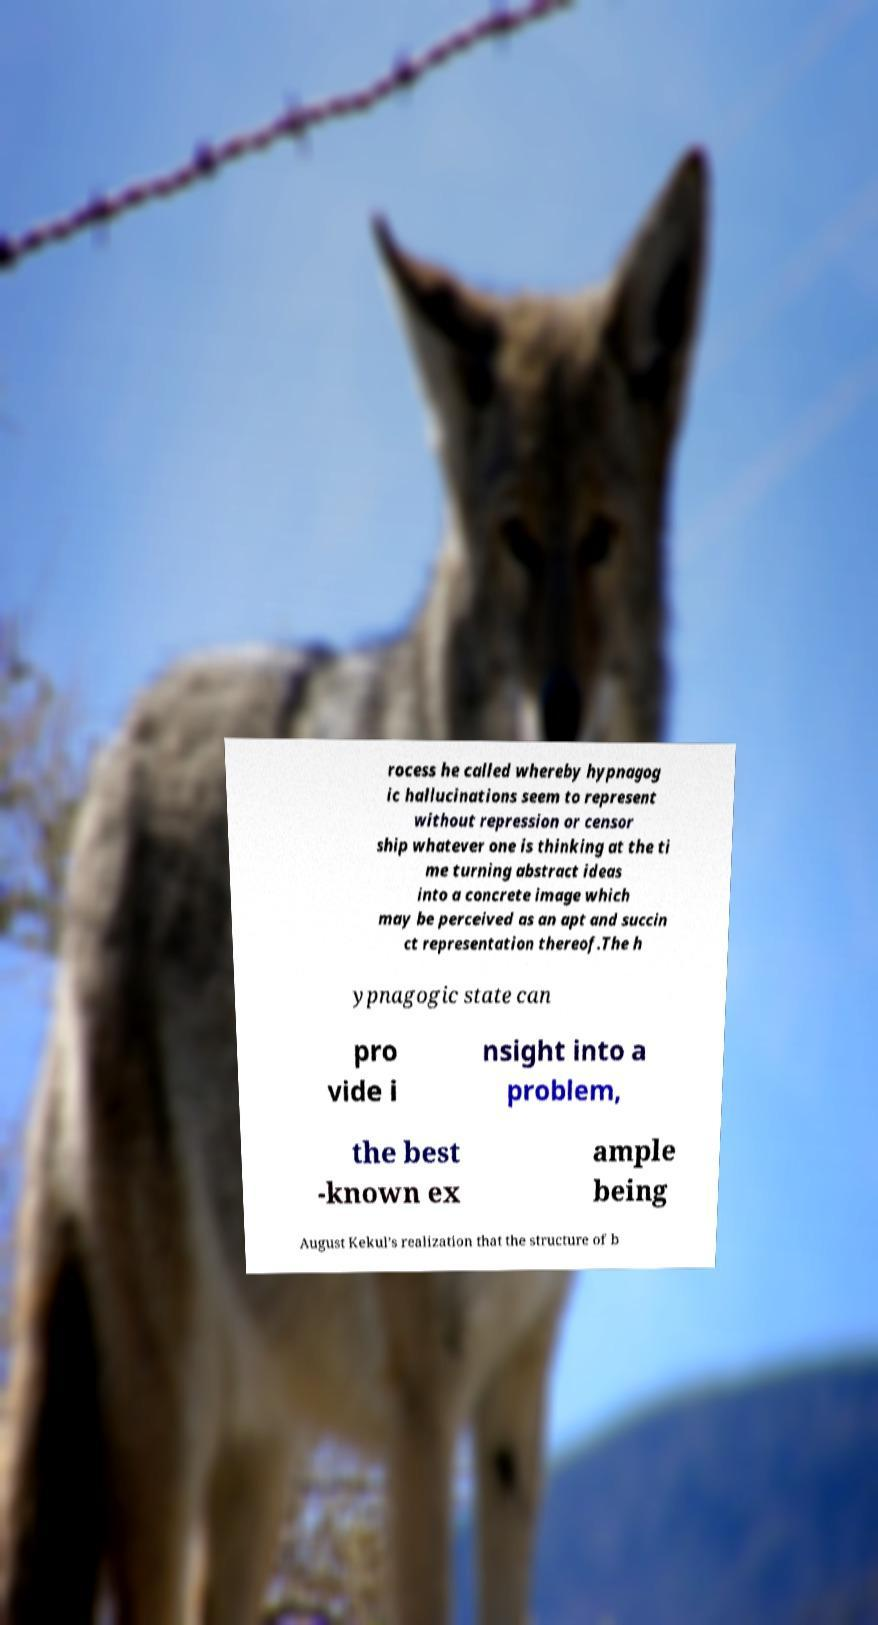There's text embedded in this image that I need extracted. Can you transcribe it verbatim? rocess he called whereby hypnagog ic hallucinations seem to represent without repression or censor ship whatever one is thinking at the ti me turning abstract ideas into a concrete image which may be perceived as an apt and succin ct representation thereof.The h ypnagogic state can pro vide i nsight into a problem, the best -known ex ample being August Kekul’s realization that the structure of b 